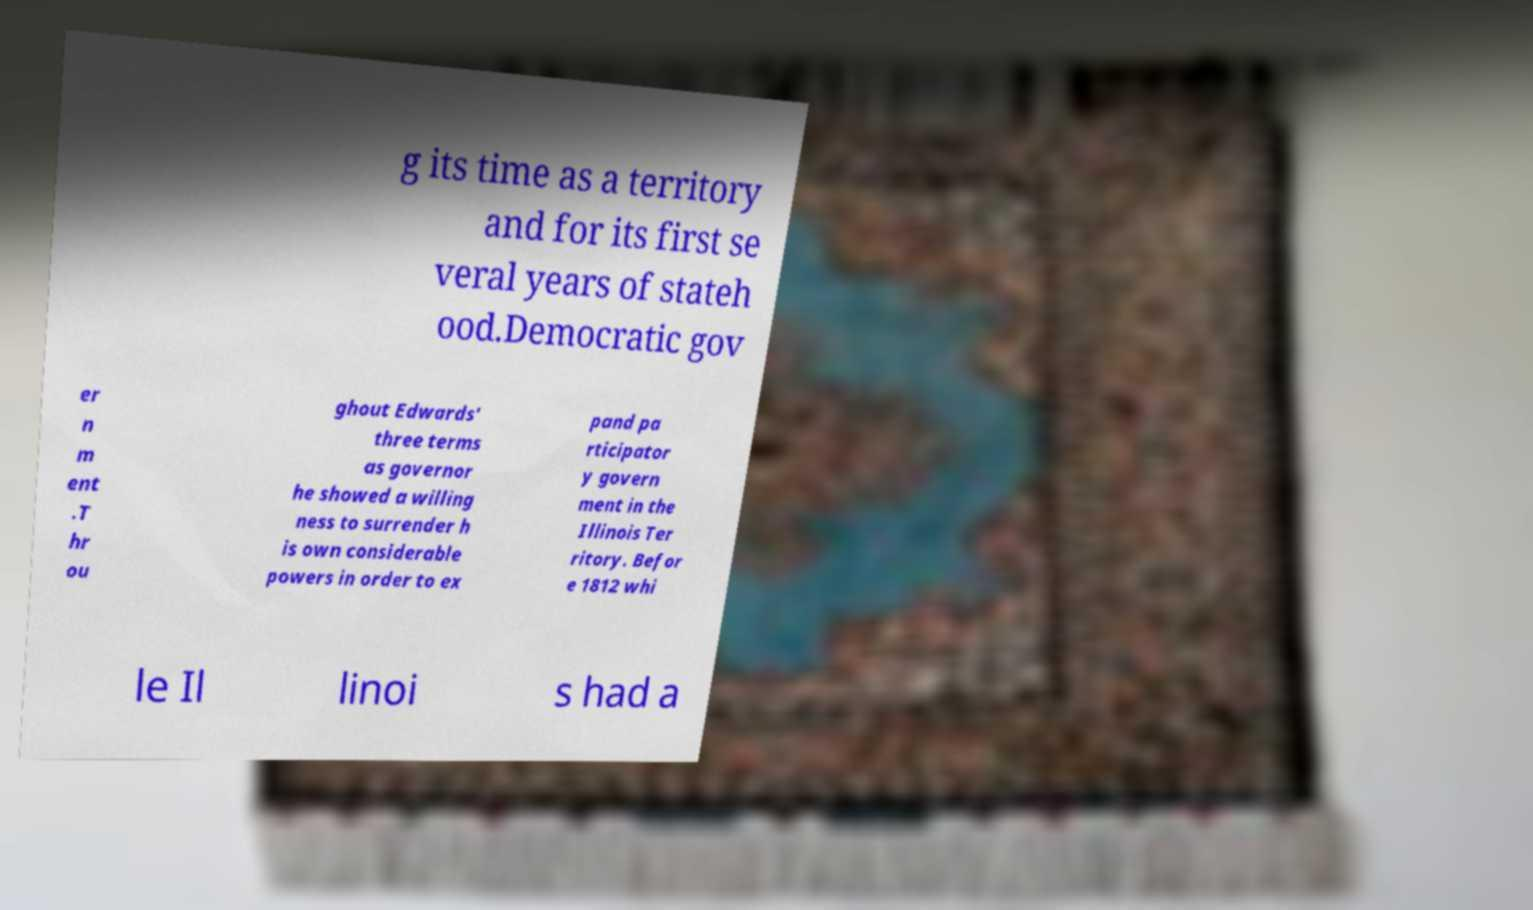Could you extract and type out the text from this image? g its time as a territory and for its first se veral years of stateh ood.Democratic gov er n m ent .T hr ou ghout Edwards' three terms as governor he showed a willing ness to surrender h is own considerable powers in order to ex pand pa rticipator y govern ment in the Illinois Ter ritory. Befor e 1812 whi le Il linoi s had a 